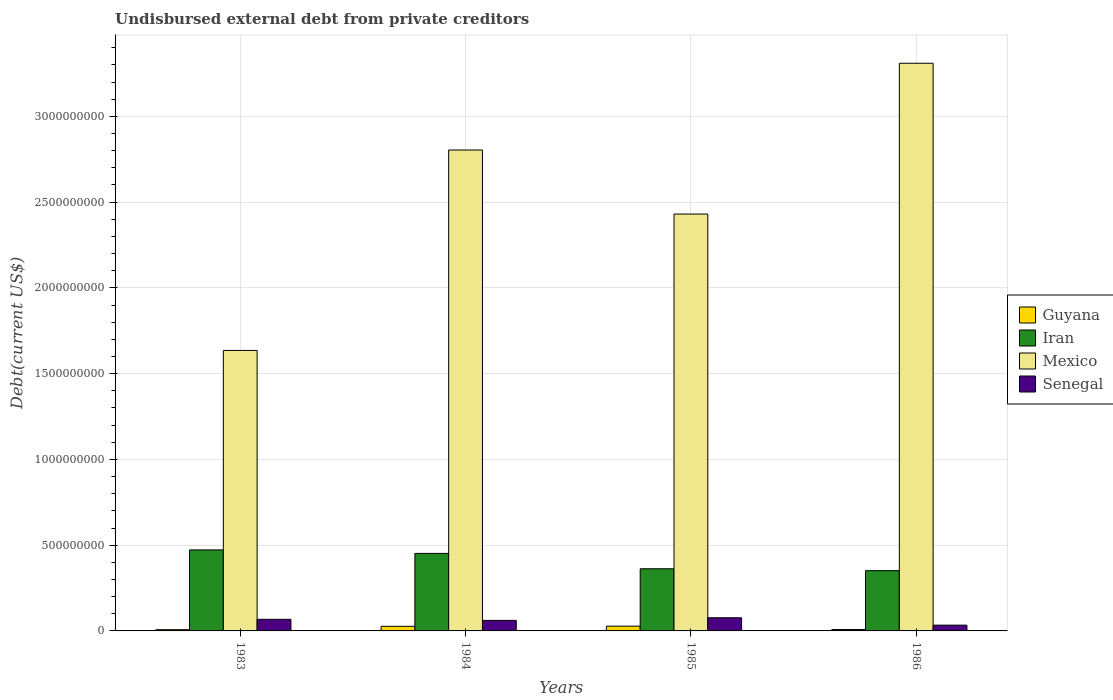How many different coloured bars are there?
Offer a terse response. 4. How many groups of bars are there?
Make the answer very short. 4. How many bars are there on the 3rd tick from the left?
Make the answer very short. 4. What is the total debt in Senegal in 1984?
Give a very brief answer. 6.14e+07. Across all years, what is the maximum total debt in Mexico?
Your answer should be very brief. 3.31e+09. Across all years, what is the minimum total debt in Guyana?
Provide a succinct answer. 7.11e+06. In which year was the total debt in Mexico minimum?
Provide a short and direct response. 1983. What is the total total debt in Guyana in the graph?
Your answer should be compact. 6.99e+07. What is the difference between the total debt in Senegal in 1983 and that in 1986?
Give a very brief answer. 3.39e+07. What is the difference between the total debt in Mexico in 1985 and the total debt in Guyana in 1984?
Offer a very short reply. 2.40e+09. What is the average total debt in Mexico per year?
Offer a terse response. 2.54e+09. In the year 1985, what is the difference between the total debt in Senegal and total debt in Guyana?
Offer a very short reply. 4.89e+07. In how many years, is the total debt in Mexico greater than 1700000000 US$?
Provide a short and direct response. 3. What is the ratio of the total debt in Guyana in 1983 to that in 1984?
Provide a succinct answer. 0.26. What is the difference between the highest and the second highest total debt in Guyana?
Ensure brevity in your answer.  1.03e+06. What is the difference between the highest and the lowest total debt in Guyana?
Your answer should be compact. 2.08e+07. Is the sum of the total debt in Senegal in 1985 and 1986 greater than the maximum total debt in Guyana across all years?
Make the answer very short. Yes. What does the 4th bar from the right in 1986 represents?
Keep it short and to the point. Guyana. Are all the bars in the graph horizontal?
Make the answer very short. No. How many years are there in the graph?
Provide a short and direct response. 4. What is the difference between two consecutive major ticks on the Y-axis?
Ensure brevity in your answer.  5.00e+08. Does the graph contain any zero values?
Offer a very short reply. No. How many legend labels are there?
Provide a short and direct response. 4. How are the legend labels stacked?
Your response must be concise. Vertical. What is the title of the graph?
Ensure brevity in your answer.  Undisbursed external debt from private creditors. What is the label or title of the Y-axis?
Your answer should be very brief. Debt(current US$). What is the Debt(current US$) in Guyana in 1983?
Your answer should be compact. 7.11e+06. What is the Debt(current US$) of Iran in 1983?
Your answer should be compact. 4.72e+08. What is the Debt(current US$) in Mexico in 1983?
Your answer should be very brief. 1.64e+09. What is the Debt(current US$) in Senegal in 1983?
Your answer should be very brief. 6.76e+07. What is the Debt(current US$) in Guyana in 1984?
Keep it short and to the point. 2.68e+07. What is the Debt(current US$) in Iran in 1984?
Offer a terse response. 4.52e+08. What is the Debt(current US$) of Mexico in 1984?
Your answer should be compact. 2.80e+09. What is the Debt(current US$) in Senegal in 1984?
Give a very brief answer. 6.14e+07. What is the Debt(current US$) of Guyana in 1985?
Provide a short and direct response. 2.79e+07. What is the Debt(current US$) of Iran in 1985?
Your response must be concise. 3.62e+08. What is the Debt(current US$) in Mexico in 1985?
Provide a short and direct response. 2.43e+09. What is the Debt(current US$) in Senegal in 1985?
Make the answer very short. 7.67e+07. What is the Debt(current US$) in Guyana in 1986?
Your answer should be compact. 8.12e+06. What is the Debt(current US$) in Iran in 1986?
Keep it short and to the point. 3.51e+08. What is the Debt(current US$) of Mexico in 1986?
Keep it short and to the point. 3.31e+09. What is the Debt(current US$) of Senegal in 1986?
Offer a very short reply. 3.37e+07. Across all years, what is the maximum Debt(current US$) of Guyana?
Your answer should be very brief. 2.79e+07. Across all years, what is the maximum Debt(current US$) in Iran?
Ensure brevity in your answer.  4.72e+08. Across all years, what is the maximum Debt(current US$) of Mexico?
Ensure brevity in your answer.  3.31e+09. Across all years, what is the maximum Debt(current US$) in Senegal?
Provide a short and direct response. 7.67e+07. Across all years, what is the minimum Debt(current US$) of Guyana?
Your response must be concise. 7.11e+06. Across all years, what is the minimum Debt(current US$) of Iran?
Offer a terse response. 3.51e+08. Across all years, what is the minimum Debt(current US$) in Mexico?
Make the answer very short. 1.64e+09. Across all years, what is the minimum Debt(current US$) of Senegal?
Ensure brevity in your answer.  3.37e+07. What is the total Debt(current US$) of Guyana in the graph?
Keep it short and to the point. 6.99e+07. What is the total Debt(current US$) in Iran in the graph?
Your answer should be very brief. 1.64e+09. What is the total Debt(current US$) in Mexico in the graph?
Ensure brevity in your answer.  1.02e+1. What is the total Debt(current US$) of Senegal in the graph?
Offer a very short reply. 2.39e+08. What is the difference between the Debt(current US$) in Guyana in 1983 and that in 1984?
Give a very brief answer. -1.97e+07. What is the difference between the Debt(current US$) in Iran in 1983 and that in 1984?
Give a very brief answer. 2.03e+07. What is the difference between the Debt(current US$) of Mexico in 1983 and that in 1984?
Make the answer very short. -1.17e+09. What is the difference between the Debt(current US$) of Senegal in 1983 and that in 1984?
Your answer should be very brief. 6.16e+06. What is the difference between the Debt(current US$) of Guyana in 1983 and that in 1985?
Your answer should be very brief. -2.08e+07. What is the difference between the Debt(current US$) of Iran in 1983 and that in 1985?
Your response must be concise. 1.10e+08. What is the difference between the Debt(current US$) of Mexico in 1983 and that in 1985?
Make the answer very short. -7.95e+08. What is the difference between the Debt(current US$) in Senegal in 1983 and that in 1985?
Provide a short and direct response. -9.11e+06. What is the difference between the Debt(current US$) in Guyana in 1983 and that in 1986?
Your response must be concise. -1.01e+06. What is the difference between the Debt(current US$) in Iran in 1983 and that in 1986?
Provide a short and direct response. 1.21e+08. What is the difference between the Debt(current US$) of Mexico in 1983 and that in 1986?
Give a very brief answer. -1.67e+09. What is the difference between the Debt(current US$) in Senegal in 1983 and that in 1986?
Offer a very short reply. 3.39e+07. What is the difference between the Debt(current US$) in Guyana in 1984 and that in 1985?
Provide a short and direct response. -1.03e+06. What is the difference between the Debt(current US$) of Iran in 1984 and that in 1985?
Offer a very short reply. 8.96e+07. What is the difference between the Debt(current US$) in Mexico in 1984 and that in 1985?
Your response must be concise. 3.73e+08. What is the difference between the Debt(current US$) in Senegal in 1984 and that in 1985?
Ensure brevity in your answer.  -1.53e+07. What is the difference between the Debt(current US$) in Guyana in 1984 and that in 1986?
Ensure brevity in your answer.  1.87e+07. What is the difference between the Debt(current US$) in Iran in 1984 and that in 1986?
Provide a short and direct response. 1.01e+08. What is the difference between the Debt(current US$) in Mexico in 1984 and that in 1986?
Offer a terse response. -5.06e+08. What is the difference between the Debt(current US$) of Senegal in 1984 and that in 1986?
Offer a terse response. 2.78e+07. What is the difference between the Debt(current US$) in Guyana in 1985 and that in 1986?
Your answer should be very brief. 1.97e+07. What is the difference between the Debt(current US$) of Iran in 1985 and that in 1986?
Offer a terse response. 1.10e+07. What is the difference between the Debt(current US$) of Mexico in 1985 and that in 1986?
Give a very brief answer. -8.79e+08. What is the difference between the Debt(current US$) in Senegal in 1985 and that in 1986?
Ensure brevity in your answer.  4.30e+07. What is the difference between the Debt(current US$) in Guyana in 1983 and the Debt(current US$) in Iran in 1984?
Make the answer very short. -4.45e+08. What is the difference between the Debt(current US$) in Guyana in 1983 and the Debt(current US$) in Mexico in 1984?
Offer a very short reply. -2.80e+09. What is the difference between the Debt(current US$) in Guyana in 1983 and the Debt(current US$) in Senegal in 1984?
Offer a terse response. -5.43e+07. What is the difference between the Debt(current US$) of Iran in 1983 and the Debt(current US$) of Mexico in 1984?
Make the answer very short. -2.33e+09. What is the difference between the Debt(current US$) in Iran in 1983 and the Debt(current US$) in Senegal in 1984?
Ensure brevity in your answer.  4.11e+08. What is the difference between the Debt(current US$) of Mexico in 1983 and the Debt(current US$) of Senegal in 1984?
Your response must be concise. 1.57e+09. What is the difference between the Debt(current US$) of Guyana in 1983 and the Debt(current US$) of Iran in 1985?
Offer a very short reply. -3.55e+08. What is the difference between the Debt(current US$) in Guyana in 1983 and the Debt(current US$) in Mexico in 1985?
Your answer should be very brief. -2.42e+09. What is the difference between the Debt(current US$) of Guyana in 1983 and the Debt(current US$) of Senegal in 1985?
Provide a short and direct response. -6.96e+07. What is the difference between the Debt(current US$) of Iran in 1983 and the Debt(current US$) of Mexico in 1985?
Your answer should be compact. -1.96e+09. What is the difference between the Debt(current US$) in Iran in 1983 and the Debt(current US$) in Senegal in 1985?
Offer a terse response. 3.96e+08. What is the difference between the Debt(current US$) of Mexico in 1983 and the Debt(current US$) of Senegal in 1985?
Give a very brief answer. 1.56e+09. What is the difference between the Debt(current US$) of Guyana in 1983 and the Debt(current US$) of Iran in 1986?
Provide a short and direct response. -3.44e+08. What is the difference between the Debt(current US$) of Guyana in 1983 and the Debt(current US$) of Mexico in 1986?
Offer a terse response. -3.30e+09. What is the difference between the Debt(current US$) of Guyana in 1983 and the Debt(current US$) of Senegal in 1986?
Offer a terse response. -2.66e+07. What is the difference between the Debt(current US$) in Iran in 1983 and the Debt(current US$) in Mexico in 1986?
Your answer should be compact. -2.84e+09. What is the difference between the Debt(current US$) in Iran in 1983 and the Debt(current US$) in Senegal in 1986?
Provide a succinct answer. 4.39e+08. What is the difference between the Debt(current US$) in Mexico in 1983 and the Debt(current US$) in Senegal in 1986?
Give a very brief answer. 1.60e+09. What is the difference between the Debt(current US$) of Guyana in 1984 and the Debt(current US$) of Iran in 1985?
Provide a succinct answer. -3.36e+08. What is the difference between the Debt(current US$) in Guyana in 1984 and the Debt(current US$) in Mexico in 1985?
Provide a short and direct response. -2.40e+09. What is the difference between the Debt(current US$) of Guyana in 1984 and the Debt(current US$) of Senegal in 1985?
Offer a very short reply. -4.99e+07. What is the difference between the Debt(current US$) of Iran in 1984 and the Debt(current US$) of Mexico in 1985?
Your answer should be very brief. -1.98e+09. What is the difference between the Debt(current US$) of Iran in 1984 and the Debt(current US$) of Senegal in 1985?
Ensure brevity in your answer.  3.75e+08. What is the difference between the Debt(current US$) in Mexico in 1984 and the Debt(current US$) in Senegal in 1985?
Provide a succinct answer. 2.73e+09. What is the difference between the Debt(current US$) in Guyana in 1984 and the Debt(current US$) in Iran in 1986?
Provide a short and direct response. -3.25e+08. What is the difference between the Debt(current US$) in Guyana in 1984 and the Debt(current US$) in Mexico in 1986?
Provide a succinct answer. -3.28e+09. What is the difference between the Debt(current US$) of Guyana in 1984 and the Debt(current US$) of Senegal in 1986?
Provide a succinct answer. -6.86e+06. What is the difference between the Debt(current US$) in Iran in 1984 and the Debt(current US$) in Mexico in 1986?
Your response must be concise. -2.86e+09. What is the difference between the Debt(current US$) in Iran in 1984 and the Debt(current US$) in Senegal in 1986?
Offer a very short reply. 4.18e+08. What is the difference between the Debt(current US$) in Mexico in 1984 and the Debt(current US$) in Senegal in 1986?
Offer a terse response. 2.77e+09. What is the difference between the Debt(current US$) in Guyana in 1985 and the Debt(current US$) in Iran in 1986?
Offer a very short reply. -3.23e+08. What is the difference between the Debt(current US$) of Guyana in 1985 and the Debt(current US$) of Mexico in 1986?
Make the answer very short. -3.28e+09. What is the difference between the Debt(current US$) in Guyana in 1985 and the Debt(current US$) in Senegal in 1986?
Make the answer very short. -5.83e+06. What is the difference between the Debt(current US$) of Iran in 1985 and the Debt(current US$) of Mexico in 1986?
Keep it short and to the point. -2.95e+09. What is the difference between the Debt(current US$) of Iran in 1985 and the Debt(current US$) of Senegal in 1986?
Offer a terse response. 3.29e+08. What is the difference between the Debt(current US$) in Mexico in 1985 and the Debt(current US$) in Senegal in 1986?
Give a very brief answer. 2.40e+09. What is the average Debt(current US$) in Guyana per year?
Give a very brief answer. 1.75e+07. What is the average Debt(current US$) in Iran per year?
Offer a terse response. 4.09e+08. What is the average Debt(current US$) in Mexico per year?
Your response must be concise. 2.54e+09. What is the average Debt(current US$) in Senegal per year?
Offer a very short reply. 5.99e+07. In the year 1983, what is the difference between the Debt(current US$) of Guyana and Debt(current US$) of Iran?
Provide a succinct answer. -4.65e+08. In the year 1983, what is the difference between the Debt(current US$) of Guyana and Debt(current US$) of Mexico?
Your answer should be compact. -1.63e+09. In the year 1983, what is the difference between the Debt(current US$) in Guyana and Debt(current US$) in Senegal?
Provide a short and direct response. -6.05e+07. In the year 1983, what is the difference between the Debt(current US$) of Iran and Debt(current US$) of Mexico?
Provide a short and direct response. -1.16e+09. In the year 1983, what is the difference between the Debt(current US$) of Iran and Debt(current US$) of Senegal?
Give a very brief answer. 4.05e+08. In the year 1983, what is the difference between the Debt(current US$) of Mexico and Debt(current US$) of Senegal?
Offer a terse response. 1.57e+09. In the year 1984, what is the difference between the Debt(current US$) in Guyana and Debt(current US$) in Iran?
Your response must be concise. -4.25e+08. In the year 1984, what is the difference between the Debt(current US$) in Guyana and Debt(current US$) in Mexico?
Provide a succinct answer. -2.78e+09. In the year 1984, what is the difference between the Debt(current US$) in Guyana and Debt(current US$) in Senegal?
Your response must be concise. -3.46e+07. In the year 1984, what is the difference between the Debt(current US$) in Iran and Debt(current US$) in Mexico?
Provide a short and direct response. -2.35e+09. In the year 1984, what is the difference between the Debt(current US$) of Iran and Debt(current US$) of Senegal?
Provide a succinct answer. 3.91e+08. In the year 1984, what is the difference between the Debt(current US$) of Mexico and Debt(current US$) of Senegal?
Your response must be concise. 2.74e+09. In the year 1985, what is the difference between the Debt(current US$) in Guyana and Debt(current US$) in Iran?
Give a very brief answer. -3.35e+08. In the year 1985, what is the difference between the Debt(current US$) in Guyana and Debt(current US$) in Mexico?
Give a very brief answer. -2.40e+09. In the year 1985, what is the difference between the Debt(current US$) in Guyana and Debt(current US$) in Senegal?
Provide a short and direct response. -4.89e+07. In the year 1985, what is the difference between the Debt(current US$) in Iran and Debt(current US$) in Mexico?
Offer a very short reply. -2.07e+09. In the year 1985, what is the difference between the Debt(current US$) of Iran and Debt(current US$) of Senegal?
Offer a terse response. 2.86e+08. In the year 1985, what is the difference between the Debt(current US$) of Mexico and Debt(current US$) of Senegal?
Your response must be concise. 2.35e+09. In the year 1986, what is the difference between the Debt(current US$) of Guyana and Debt(current US$) of Iran?
Offer a terse response. -3.43e+08. In the year 1986, what is the difference between the Debt(current US$) in Guyana and Debt(current US$) in Mexico?
Ensure brevity in your answer.  -3.30e+09. In the year 1986, what is the difference between the Debt(current US$) in Guyana and Debt(current US$) in Senegal?
Offer a very short reply. -2.56e+07. In the year 1986, what is the difference between the Debt(current US$) in Iran and Debt(current US$) in Mexico?
Your answer should be compact. -2.96e+09. In the year 1986, what is the difference between the Debt(current US$) of Iran and Debt(current US$) of Senegal?
Ensure brevity in your answer.  3.18e+08. In the year 1986, what is the difference between the Debt(current US$) of Mexico and Debt(current US$) of Senegal?
Give a very brief answer. 3.28e+09. What is the ratio of the Debt(current US$) in Guyana in 1983 to that in 1984?
Your answer should be compact. 0.26. What is the ratio of the Debt(current US$) of Iran in 1983 to that in 1984?
Make the answer very short. 1.04. What is the ratio of the Debt(current US$) of Mexico in 1983 to that in 1984?
Offer a terse response. 0.58. What is the ratio of the Debt(current US$) of Senegal in 1983 to that in 1984?
Make the answer very short. 1.1. What is the ratio of the Debt(current US$) in Guyana in 1983 to that in 1985?
Ensure brevity in your answer.  0.26. What is the ratio of the Debt(current US$) of Iran in 1983 to that in 1985?
Your response must be concise. 1.3. What is the ratio of the Debt(current US$) of Mexico in 1983 to that in 1985?
Keep it short and to the point. 0.67. What is the ratio of the Debt(current US$) of Senegal in 1983 to that in 1985?
Your answer should be compact. 0.88. What is the ratio of the Debt(current US$) in Guyana in 1983 to that in 1986?
Make the answer very short. 0.88. What is the ratio of the Debt(current US$) in Iran in 1983 to that in 1986?
Offer a very short reply. 1.34. What is the ratio of the Debt(current US$) of Mexico in 1983 to that in 1986?
Provide a succinct answer. 0.49. What is the ratio of the Debt(current US$) of Senegal in 1983 to that in 1986?
Provide a short and direct response. 2.01. What is the ratio of the Debt(current US$) of Guyana in 1984 to that in 1985?
Offer a terse response. 0.96. What is the ratio of the Debt(current US$) of Iran in 1984 to that in 1985?
Make the answer very short. 1.25. What is the ratio of the Debt(current US$) in Mexico in 1984 to that in 1985?
Provide a short and direct response. 1.15. What is the ratio of the Debt(current US$) of Senegal in 1984 to that in 1985?
Make the answer very short. 0.8. What is the ratio of the Debt(current US$) in Guyana in 1984 to that in 1986?
Keep it short and to the point. 3.31. What is the ratio of the Debt(current US$) of Iran in 1984 to that in 1986?
Keep it short and to the point. 1.29. What is the ratio of the Debt(current US$) in Mexico in 1984 to that in 1986?
Offer a terse response. 0.85. What is the ratio of the Debt(current US$) of Senegal in 1984 to that in 1986?
Your answer should be very brief. 1.82. What is the ratio of the Debt(current US$) of Guyana in 1985 to that in 1986?
Provide a short and direct response. 3.43. What is the ratio of the Debt(current US$) of Iran in 1985 to that in 1986?
Provide a succinct answer. 1.03. What is the ratio of the Debt(current US$) of Mexico in 1985 to that in 1986?
Keep it short and to the point. 0.73. What is the ratio of the Debt(current US$) in Senegal in 1985 to that in 1986?
Provide a short and direct response. 2.28. What is the difference between the highest and the second highest Debt(current US$) of Guyana?
Ensure brevity in your answer.  1.03e+06. What is the difference between the highest and the second highest Debt(current US$) in Iran?
Offer a very short reply. 2.03e+07. What is the difference between the highest and the second highest Debt(current US$) in Mexico?
Your answer should be compact. 5.06e+08. What is the difference between the highest and the second highest Debt(current US$) in Senegal?
Offer a very short reply. 9.11e+06. What is the difference between the highest and the lowest Debt(current US$) in Guyana?
Keep it short and to the point. 2.08e+07. What is the difference between the highest and the lowest Debt(current US$) of Iran?
Give a very brief answer. 1.21e+08. What is the difference between the highest and the lowest Debt(current US$) of Mexico?
Your answer should be very brief. 1.67e+09. What is the difference between the highest and the lowest Debt(current US$) of Senegal?
Keep it short and to the point. 4.30e+07. 